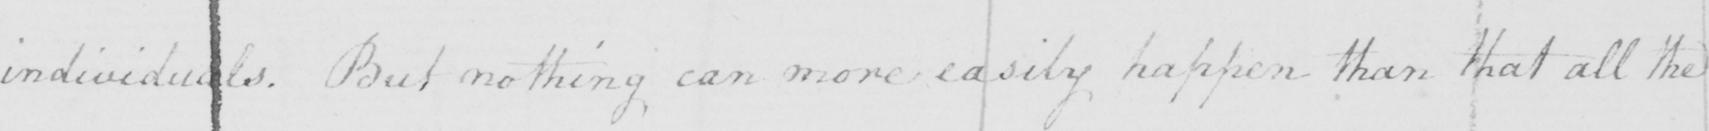Please transcribe the handwritten text in this image. individuals . But nothing can more easily happen than that all the 